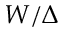Convert formula to latex. <formula><loc_0><loc_0><loc_500><loc_500>W / \Delta</formula> 